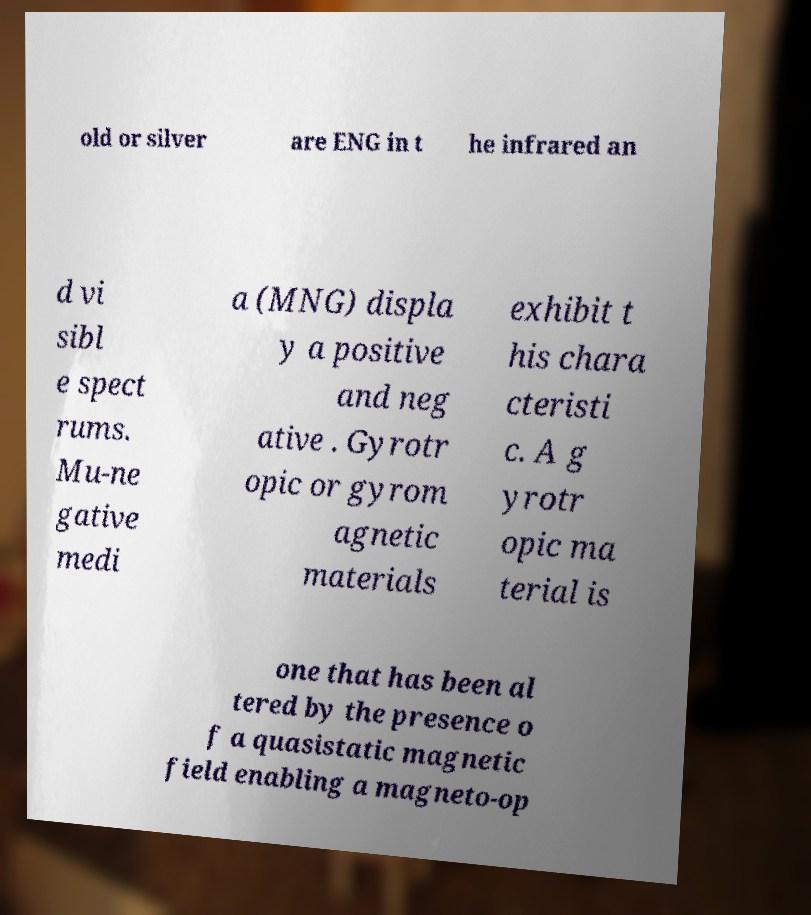Can you accurately transcribe the text from the provided image for me? old or silver are ENG in t he infrared an d vi sibl e spect rums. Mu-ne gative medi a (MNG) displa y a positive and neg ative . Gyrotr opic or gyrom agnetic materials exhibit t his chara cteristi c. A g yrotr opic ma terial is one that has been al tered by the presence o f a quasistatic magnetic field enabling a magneto-op 